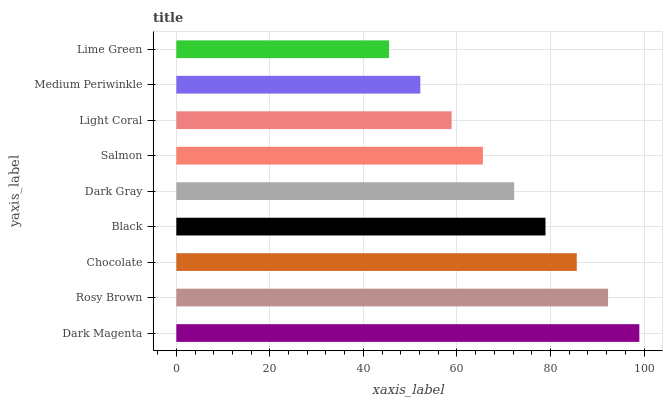Is Lime Green the minimum?
Answer yes or no. Yes. Is Dark Magenta the maximum?
Answer yes or no. Yes. Is Rosy Brown the minimum?
Answer yes or no. No. Is Rosy Brown the maximum?
Answer yes or no. No. Is Dark Magenta greater than Rosy Brown?
Answer yes or no. Yes. Is Rosy Brown less than Dark Magenta?
Answer yes or no. Yes. Is Rosy Brown greater than Dark Magenta?
Answer yes or no. No. Is Dark Magenta less than Rosy Brown?
Answer yes or no. No. Is Dark Gray the high median?
Answer yes or no. Yes. Is Dark Gray the low median?
Answer yes or no. Yes. Is Medium Periwinkle the high median?
Answer yes or no. No. Is Chocolate the low median?
Answer yes or no. No. 